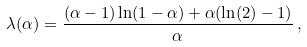<formula> <loc_0><loc_0><loc_500><loc_500>\lambda ( \alpha ) = \frac { ( \alpha - 1 ) \ln ( 1 - \alpha ) + \alpha ( \ln ( 2 ) - 1 ) } { \alpha } \, ,</formula> 